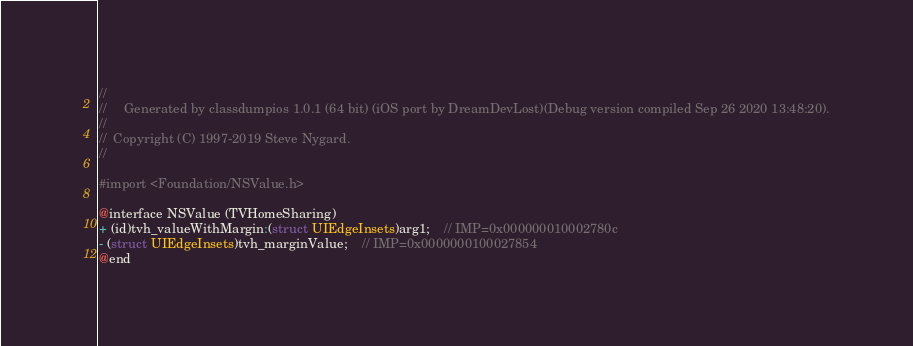<code> <loc_0><loc_0><loc_500><loc_500><_C_>//
//     Generated by classdumpios 1.0.1 (64 bit) (iOS port by DreamDevLost)(Debug version compiled Sep 26 2020 13:48:20).
//
//  Copyright (C) 1997-2019 Steve Nygard.
//

#import <Foundation/NSValue.h>

@interface NSValue (TVHomeSharing)
+ (id)tvh_valueWithMargin:(struct UIEdgeInsets)arg1;	// IMP=0x000000010002780c
- (struct UIEdgeInsets)tvh_marginValue;	// IMP=0x0000000100027854
@end

</code> 